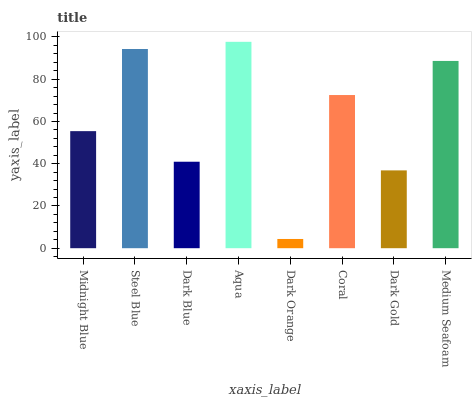Is Dark Orange the minimum?
Answer yes or no. Yes. Is Aqua the maximum?
Answer yes or no. Yes. Is Steel Blue the minimum?
Answer yes or no. No. Is Steel Blue the maximum?
Answer yes or no. No. Is Steel Blue greater than Midnight Blue?
Answer yes or no. Yes. Is Midnight Blue less than Steel Blue?
Answer yes or no. Yes. Is Midnight Blue greater than Steel Blue?
Answer yes or no. No. Is Steel Blue less than Midnight Blue?
Answer yes or no. No. Is Coral the high median?
Answer yes or no. Yes. Is Midnight Blue the low median?
Answer yes or no. Yes. Is Aqua the high median?
Answer yes or no. No. Is Coral the low median?
Answer yes or no. No. 